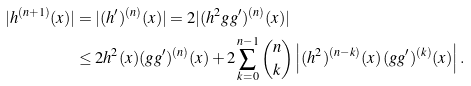Convert formula to latex. <formula><loc_0><loc_0><loc_500><loc_500>| h ^ { ( n + 1 ) } ( x ) | & = | ( h ^ { \prime } ) ^ { ( n ) } ( x ) | = 2 | ( h ^ { 2 } g g ^ { \prime } ) ^ { ( n ) } ( x ) | \\ & \leq 2 h ^ { 2 } ( x ) ( g g ^ { \prime } ) ^ { ( n ) } ( x ) + 2 \sum _ { k = 0 } ^ { n - 1 } \binom { n } { k } \left | ( h ^ { 2 } ) ^ { ( n - k ) } ( x ) \, ( g g ^ { \prime } ) ^ { ( k ) } ( x ) \right | .</formula> 